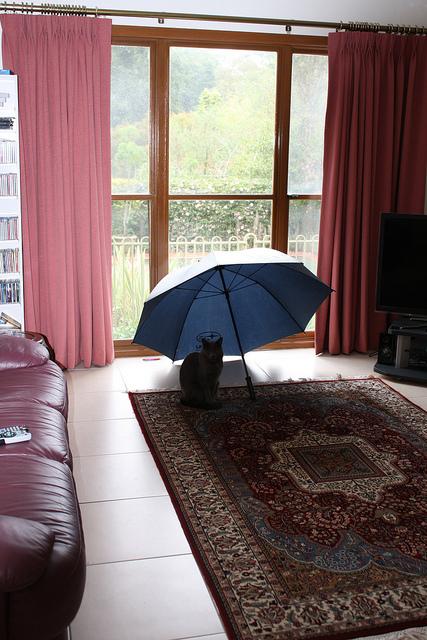What color is the umbrella?
Write a very short answer. Blue. Under an umbrella?
Quick response, please. Cat. What is the cat sitting under?
Short answer required. Umbrella. 